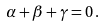<formula> <loc_0><loc_0><loc_500><loc_500>\alpha + \beta + \gamma = 0 \, .</formula> 